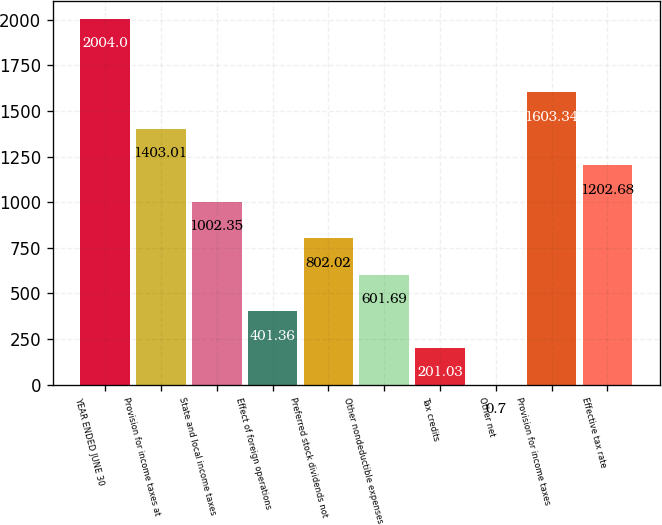Convert chart to OTSL. <chart><loc_0><loc_0><loc_500><loc_500><bar_chart><fcel>YEAR ENDED JUNE 30<fcel>Provision for income taxes at<fcel>State and local income taxes<fcel>Effect of foreign operations<fcel>Preferred stock dividends not<fcel>Other nondeductible expenses<fcel>Tax credits<fcel>Other net<fcel>Provision for income taxes<fcel>Effective tax rate<nl><fcel>2004<fcel>1403.01<fcel>1002.35<fcel>401.36<fcel>802.02<fcel>601.69<fcel>201.03<fcel>0.7<fcel>1603.34<fcel>1202.68<nl></chart> 